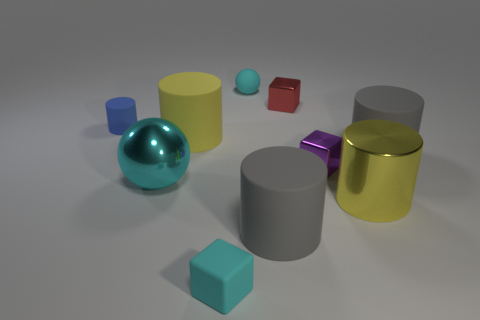Can you tell me which object is the largest? The largest object in the image appears to be the grey cylinder on the right side, judging by its relative proportions to the surrounding objects. 